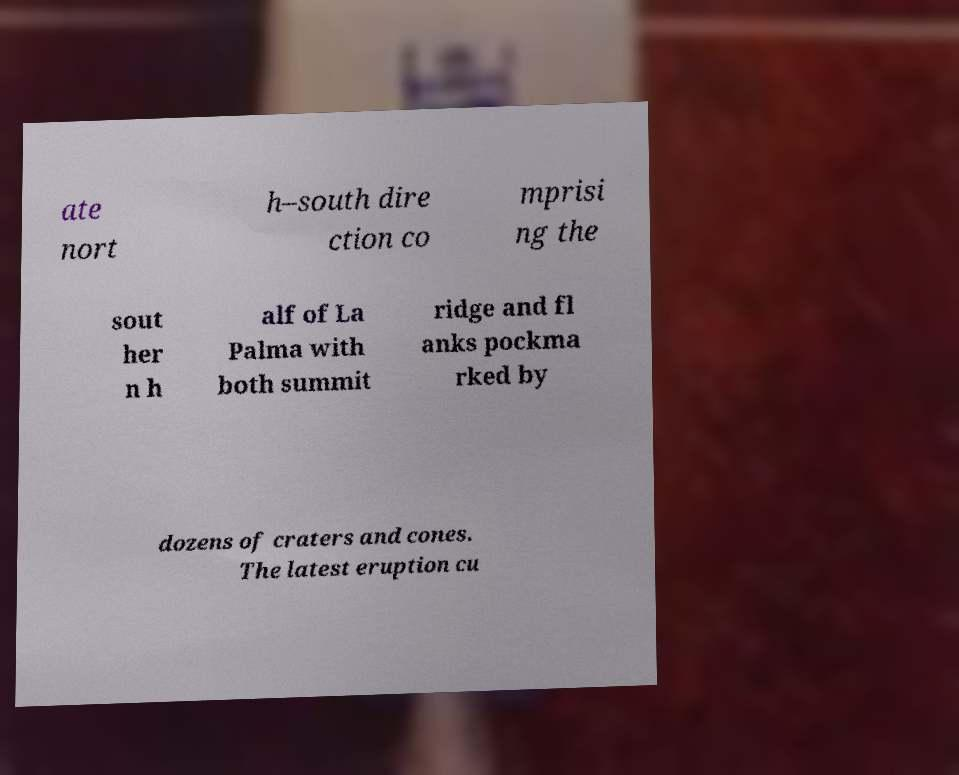Please identify and transcribe the text found in this image. ate nort h–south dire ction co mprisi ng the sout her n h alf of La Palma with both summit ridge and fl anks pockma rked by dozens of craters and cones. The latest eruption cu 